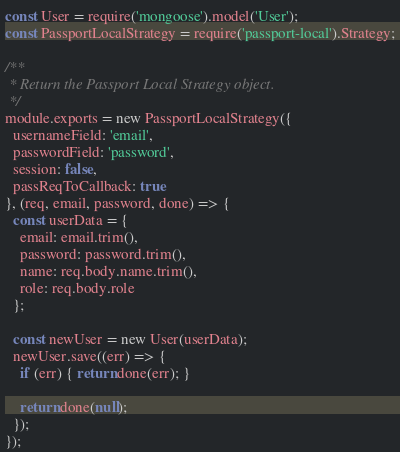Convert code to text. <code><loc_0><loc_0><loc_500><loc_500><_JavaScript_>const User = require('mongoose').model('User');
const PassportLocalStrategy = require('passport-local').Strategy;

/**
 * Return the Passport Local Strategy object.
 */
module.exports = new PassportLocalStrategy({
  usernameField: 'email',
  passwordField: 'password',
  session: false,
  passReqToCallback: true
}, (req, email, password, done) => {
  const userData = {
    email: email.trim(),
    password: password.trim(),
    name: req.body.name.trim(),
    role: req.body.role
  };

  const newUser = new User(userData);
  newUser.save((err) => {
    if (err) { return done(err); }

    return done(null);
  });
});
</code> 